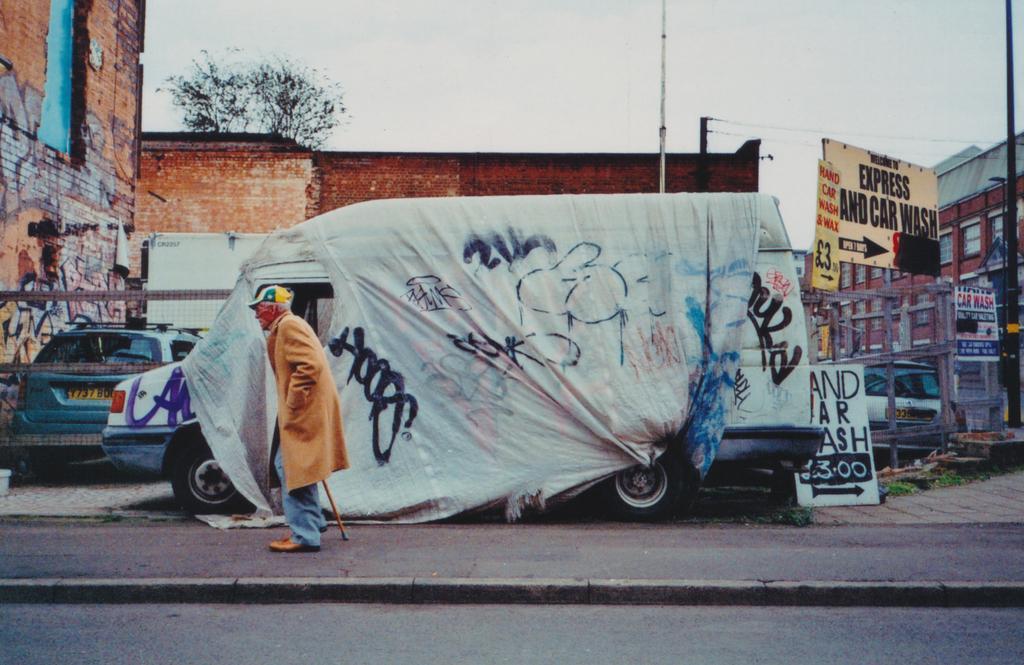Can you describe this image briefly? In this picture we can see a man walking here, in the background there is a vehicle, we can see a cloth here, there is a hoarding here, on the right side there is a building, we can see a pole here, there is a tree here, on the left side there is a car, we can see the sky at the top of the picture. 